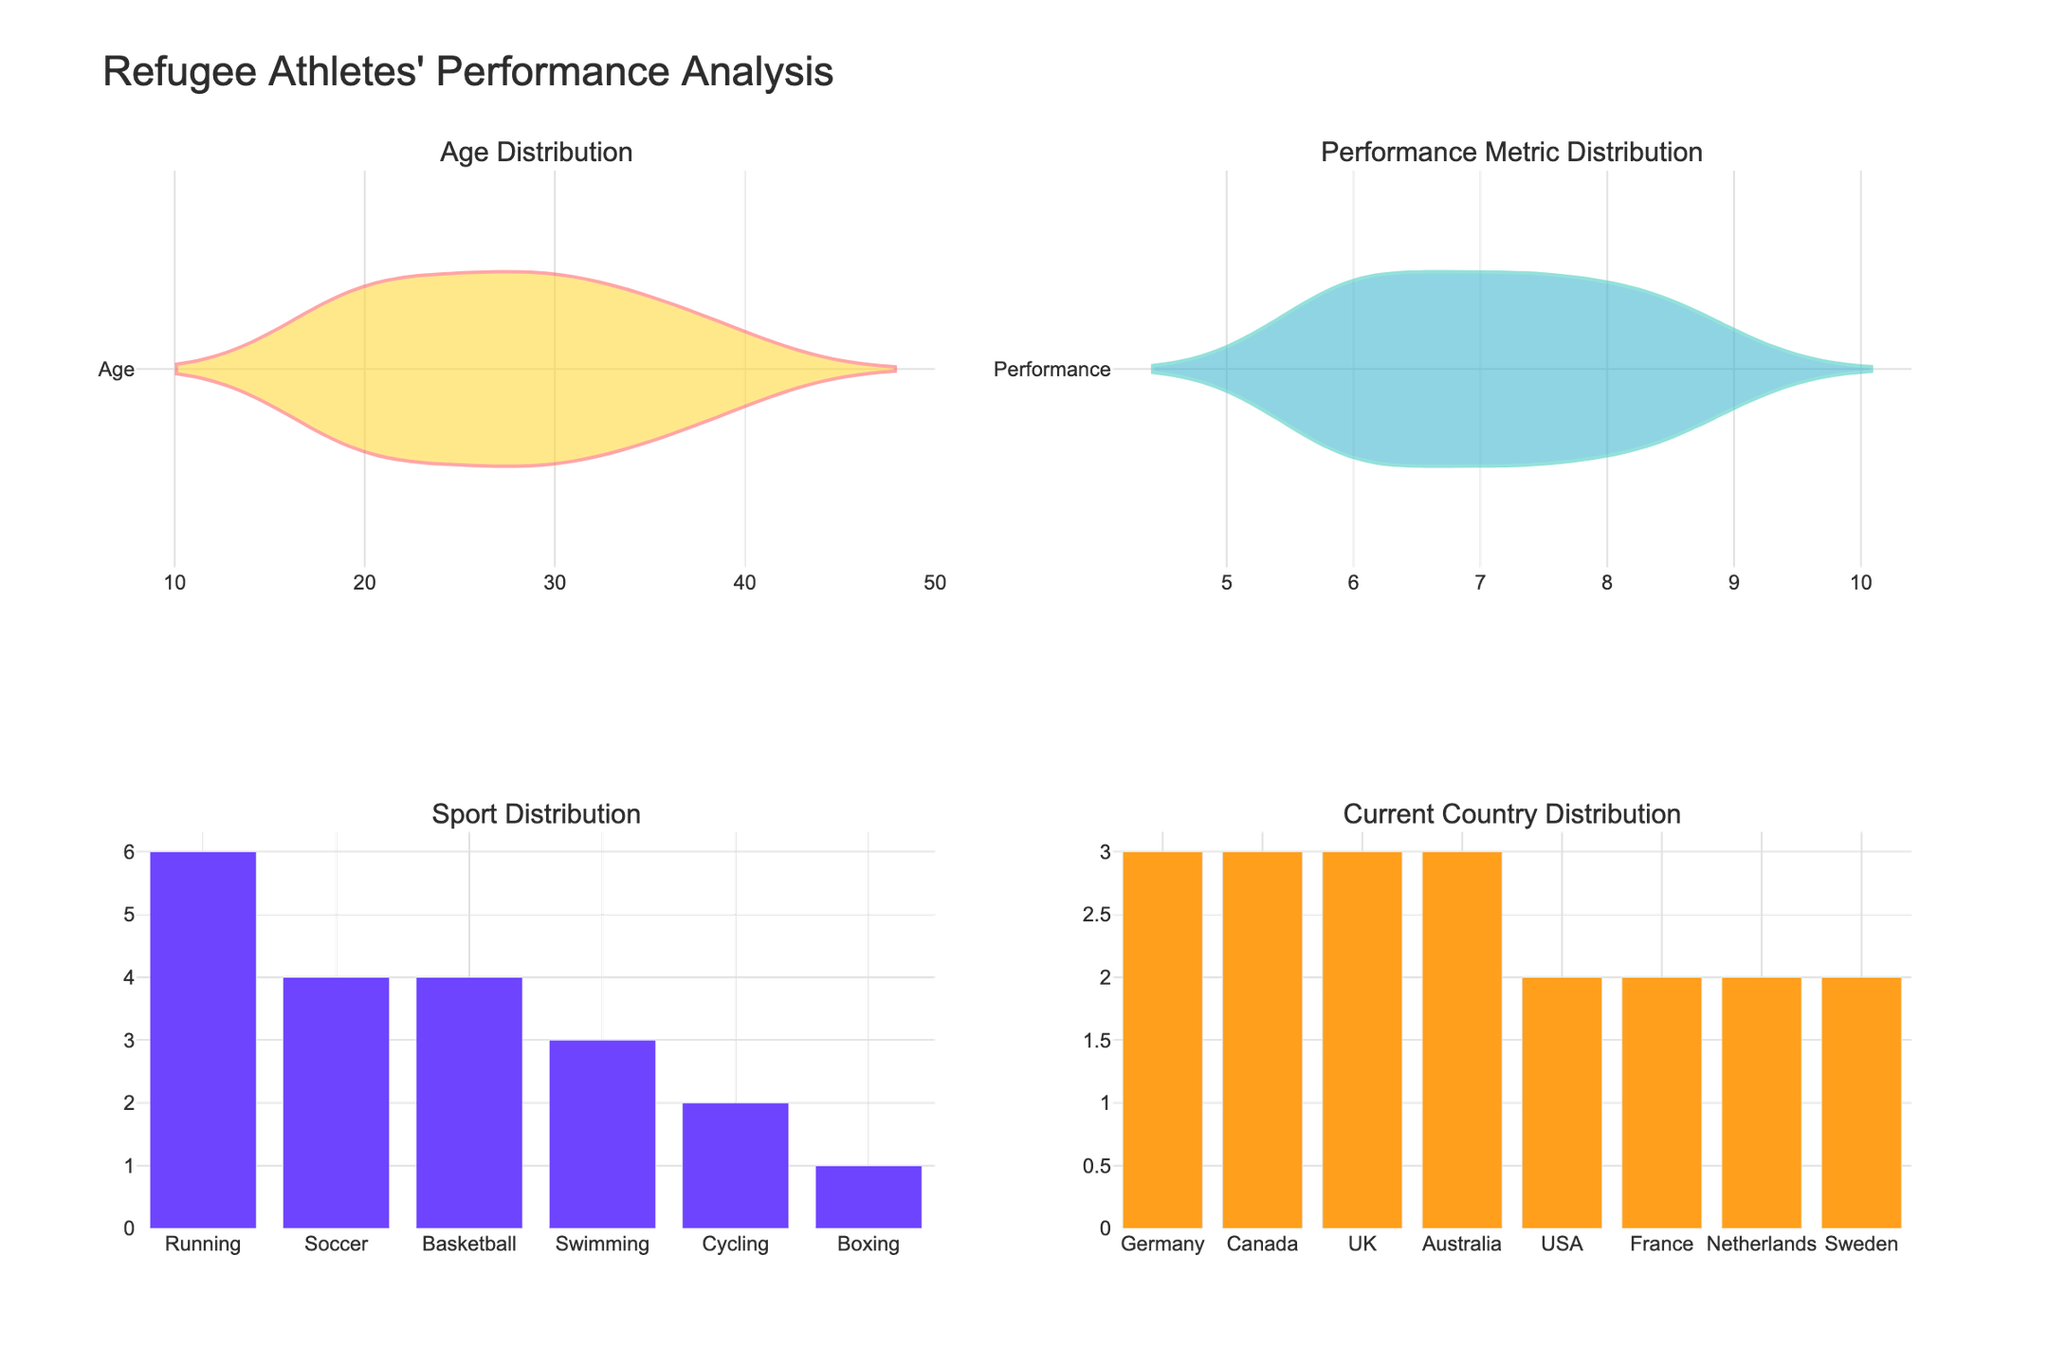What's the title of the figure? The title is usually found at the top of the figure and describes what the figure represents.
Answer: Refugee Athletes' Performance Analysis What does the distribution of ages look like? This question refers to the violin plot in the subplot labeled "Age Distribution." The violin plot shows the distribution of ages among the athletes, indicating density and spread.
Answer: The ages range from 18 to 40 with peaks around 18-23 and 31-35 Which sport has the highest number of athletes? Check the bar plot in the "Sport Distribution" subplot. The tallest bar corresponds to the sport with the highest count.
Answer: Running How many countries are represented in the "Current Country Distribution" subplot? Count the number of unique bars in the "Current Country Distribution" subplot, as each bar represents a different country.
Answer: 6 What is the most common current country for the athletes? Identify the tallest bar in the "Current Country Distribution" subplot, which represents the country with the highest number of athletes.
Answer: Germany What is the range of the Performance Metric? Examine the "Performance Metric Distribution" subplot. Identify the minimum and maximum values shown in the violin plot.
Answer: 5.6 to 8.9 Between which two sports is the number of athletes almost equal? Compare the heights of the bars in the "Sport Distribution" subplot to find two bars of almost the same height.
Answer: Soccer and Basketball What age group shows the highest density in the age distribution? Find the part of the violin plot in the "Age Distribution" subplot where the plot is the widest, indicating higher density.
Answer: 18-23 How does the performance metric distribution compare to the age distribution's spread? Compare the widths and spread in the violin plots of both the "Performance Metric Distribution" and the "Age Distribution." Note if one shows more variability.
Answer: The Performance Metric shows less variability compared to the Age Distribution What is the median performance metric among the athletes? The median is typically found at the point where the density is balanced in the violin plot. Look for the line in the middle of the "Performance Metric Distribution" violin plot.
Answer: 7.3 